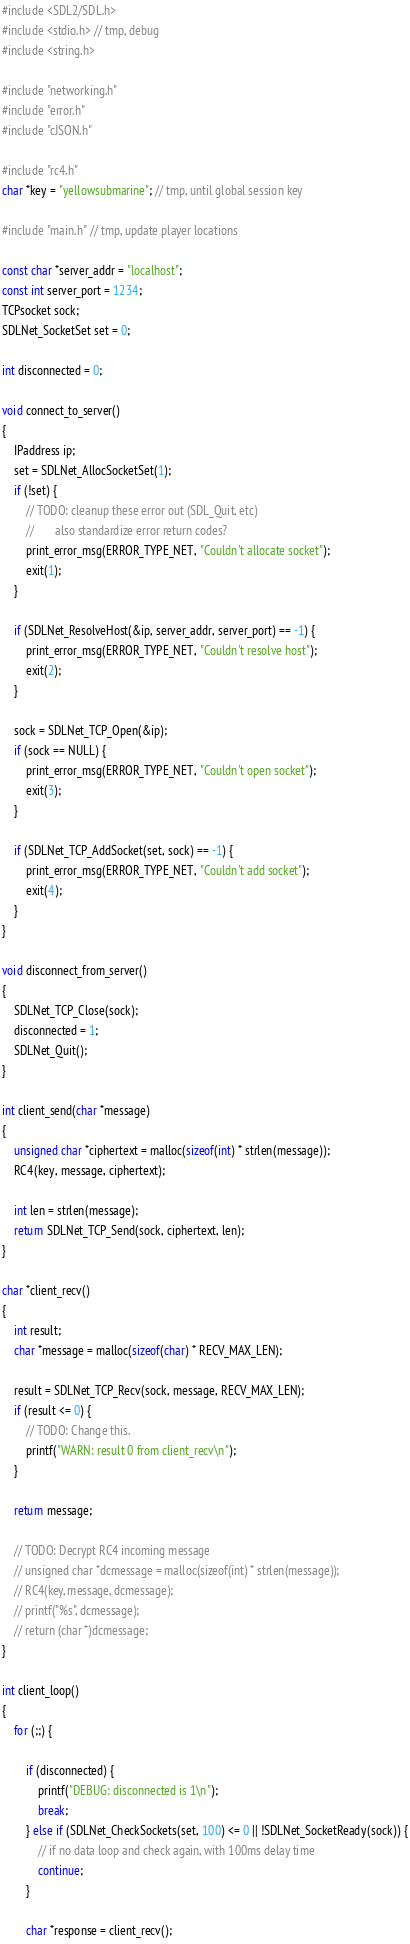Convert code to text. <code><loc_0><loc_0><loc_500><loc_500><_C_>#include <SDL2/SDL.h>
#include <stdio.h> // tmp, debug
#include <string.h>

#include "networking.h"
#include "error.h"
#include "cJSON.h"

#include "rc4.h"
char *key = "yellowsubmarine"; // tmp, until global session key

#include "main.h" // tmp, update player locations

const char *server_addr = "localhost";
const int server_port = 1234;
TCPsocket sock;
SDLNet_SocketSet set = 0;

int disconnected = 0;

void connect_to_server()
{
	IPaddress ip;
	set = SDLNet_AllocSocketSet(1);
	if (!set) {
		// TODO: cleanup these error out (SDL_Quit, etc)
		//       also standardize error return codes?
		print_error_msg(ERROR_TYPE_NET, "Couldn't allocate socket");
		exit(1);
	}

	if (SDLNet_ResolveHost(&ip, server_addr, server_port) == -1) {
		print_error_msg(ERROR_TYPE_NET, "Couldn't resolve host");
		exit(2);
	}

	sock = SDLNet_TCP_Open(&ip);
	if (sock == NULL) {
		print_error_msg(ERROR_TYPE_NET, "Couldn't open socket");
		exit(3);
	}

	if (SDLNet_TCP_AddSocket(set, sock) == -1) {
		print_error_msg(ERROR_TYPE_NET, "Couldn't add socket");
		exit(4);
	}
}

void disconnect_from_server()
{
	SDLNet_TCP_Close(sock);
	disconnected = 1;
	SDLNet_Quit();
}

int client_send(char *message)
{
	unsigned char *ciphertext = malloc(sizeof(int) * strlen(message));
	RC4(key, message, ciphertext);

	int len = strlen(message);
	return SDLNet_TCP_Send(sock, ciphertext, len);
}

char *client_recv()
{
	int result;
	char *message = malloc(sizeof(char) * RECV_MAX_LEN);

	result = SDLNet_TCP_Recv(sock, message, RECV_MAX_LEN);
	if (result <= 0) {
		// TODO: Change this.
		printf("WARN: result 0 from client_recv\n");
	}

	return message;

	// TODO: Decrypt RC4 incoming message
	// unsigned char *dcmessage = malloc(sizeof(int) * strlen(message));
	// RC4(key, message, dcmessage);
	// printf("%s", dcmessage);
	// return (char *)dcmessage;
}

int client_loop()
{
	for (;;) {

		if (disconnected) {
			printf("DEBUG: disconnected is 1\n");
			break;
		} else if (SDLNet_CheckSockets(set, 100) <= 0 || !SDLNet_SocketReady(sock)) {
			// if no data loop and check again, with 100ms delay time
			continue;
		}

		char *response = client_recv();</code> 